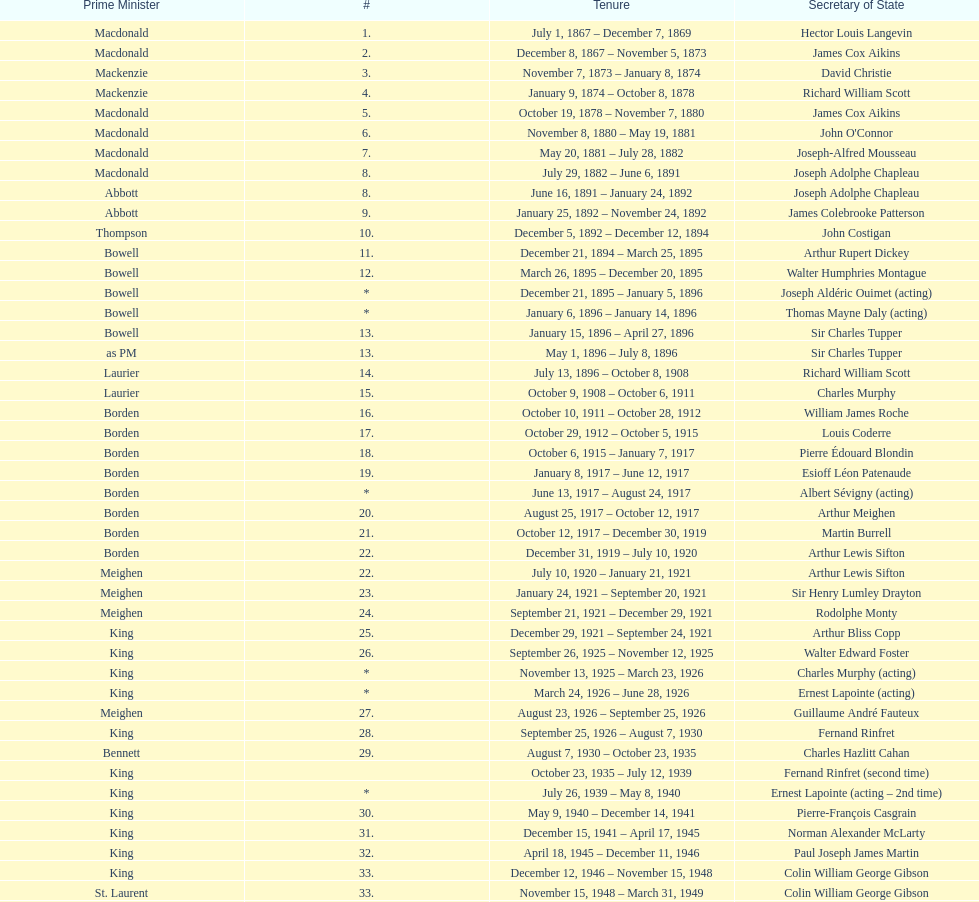How many secretaries of state had the last name bouchard? 2. 